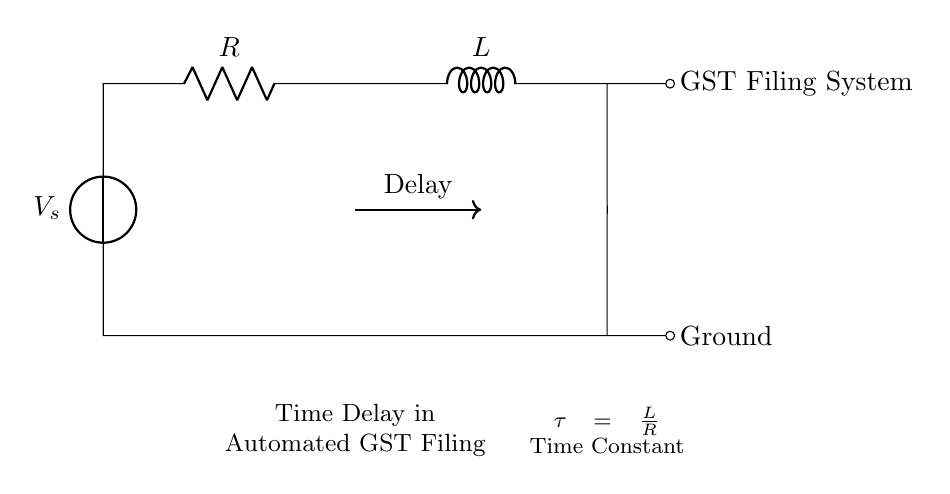What components are present in this circuit? The circuit includes a voltage source, a resistor, and an inductor. These components are essential for creating an RL circuit.
Answer: voltage source, resistor, inductor What is the role of the resistor in this circuit? The resistor limits the current flowing through the circuit and contributes to the time constant of the RL circuit, affecting how quickly the current builds up when the circuit is activated.
Answer: limits current What is the time constant formula in this circuit? The time constant for an RL circuit is defined by the formula tau equals L divided by R. This relationship shows how the inductor and resistor interact to determine the time delay.
Answer: tau = L/R What effect does increasing the resistance have on the time delay? Increasing the resistance will increase the time constant, leading to a longer time delay in the current reaching its maximum value. This means the system responds more slowly.
Answer: longer delay If the inductance is doubled, how does it affect the time constant? Doubling the inductance will directly double the time constant, thus increasing the time delay proportional to the increase in inductance. This leads to slower responses in the circuit.
Answer: increases delay What does the arrow leading to the "Delay" indicate? The arrow indicates that there is a time delay associated with the circuit behavior, highlighting that the response time of the system is influenced by the resistor and inductor.
Answer: time delay 